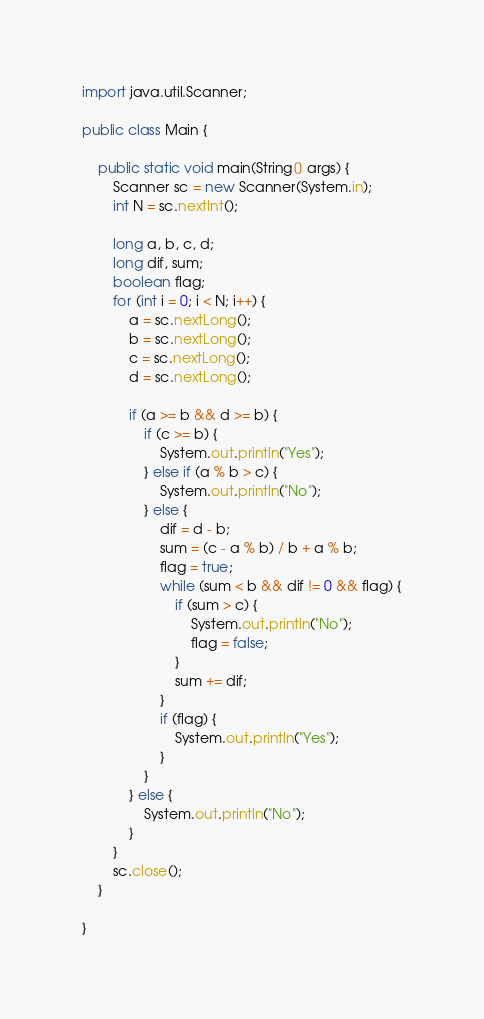Convert code to text. <code><loc_0><loc_0><loc_500><loc_500><_Java_>import java.util.Scanner;

public class Main {

	public static void main(String[] args) {
		Scanner sc = new Scanner(System.in);
		int N = sc.nextInt();

		long a, b, c, d;
		long dif, sum;
		boolean flag;
		for (int i = 0; i < N; i++) {
			a = sc.nextLong();
			b = sc.nextLong();
			c = sc.nextLong();
			d = sc.nextLong();

			if (a >= b && d >= b) {
				if (c >= b) {
					System.out.println("Yes");
				} else if (a % b > c) {
					System.out.println("No");
				} else {
					dif = d - b;
					sum = (c - a % b) / b + a % b;
					flag = true;
					while (sum < b && dif != 0 && flag) {
						if (sum > c) {
							System.out.println("No");
							flag = false;
						}
						sum += dif;
					}
					if (flag) {
						System.out.println("Yes");
					}
				}
			} else {
				System.out.println("No");
			}
		}
		sc.close();
	}

}
</code> 